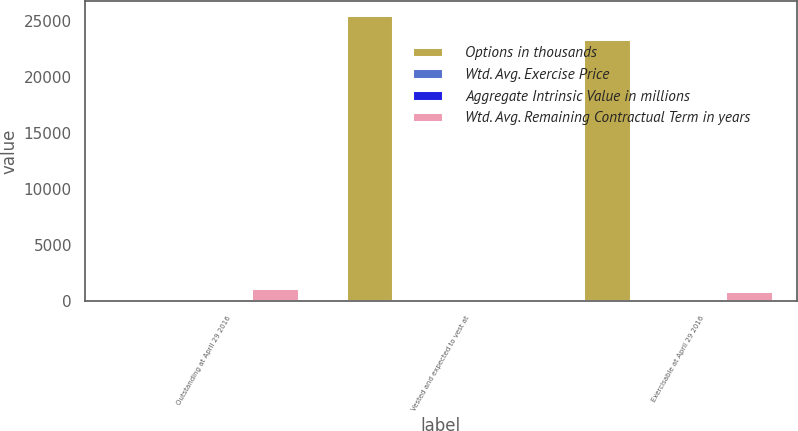<chart> <loc_0><loc_0><loc_500><loc_500><stacked_bar_chart><ecel><fcel>Outstanding at April 29 2016<fcel>Vested and expected to vest at<fcel>Exercisable at April 29 2016<nl><fcel>Options in thousands<fcel>69.91<fcel>25542<fcel>23383<nl><fcel>Wtd. Avg. Exercise Price<fcel>57.09<fcel>69.91<fcel>40.14<nl><fcel>Aggregate Intrinsic Value in millions<fcel>6.47<fcel>8.48<fcel>3.9<nl><fcel>Wtd. Avg. Remaining Contractual Term in years<fcel>1168<fcel>236<fcel>912<nl></chart> 